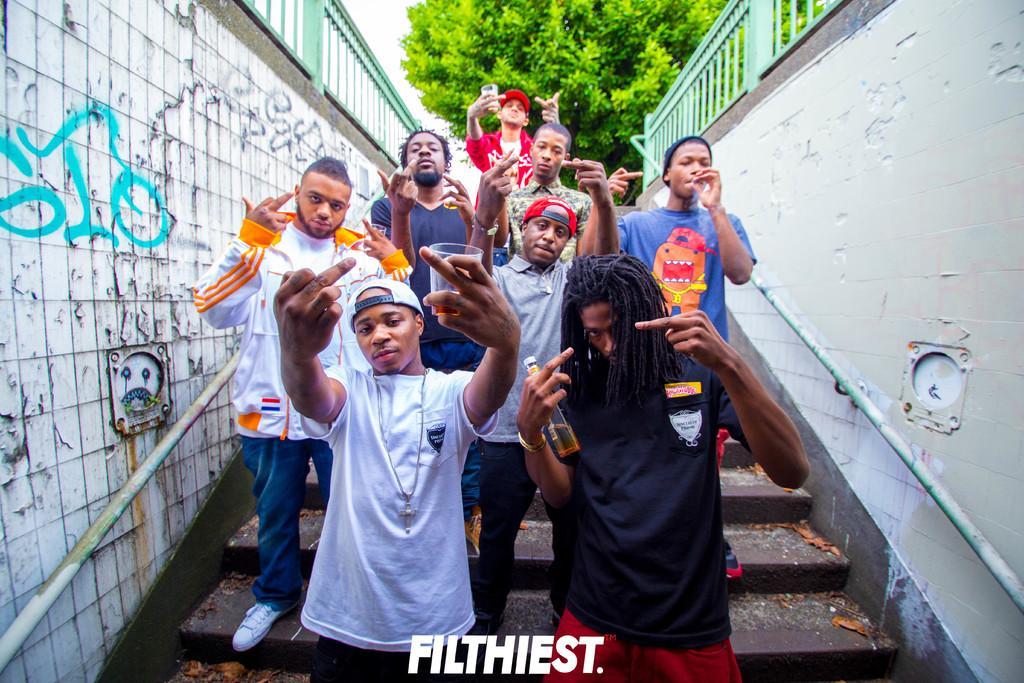Can you describe this image briefly? In this picture we can see a group of boys, standing on the steps and holding the glass in the hands and giving a pose to the camera. On both sides we can see the white walls and green railing. Behind there is a trees. 